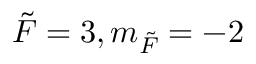<formula> <loc_0><loc_0><loc_500><loc_500>\tilde { F } = 3 , m _ { \tilde { F } } = - 2</formula> 